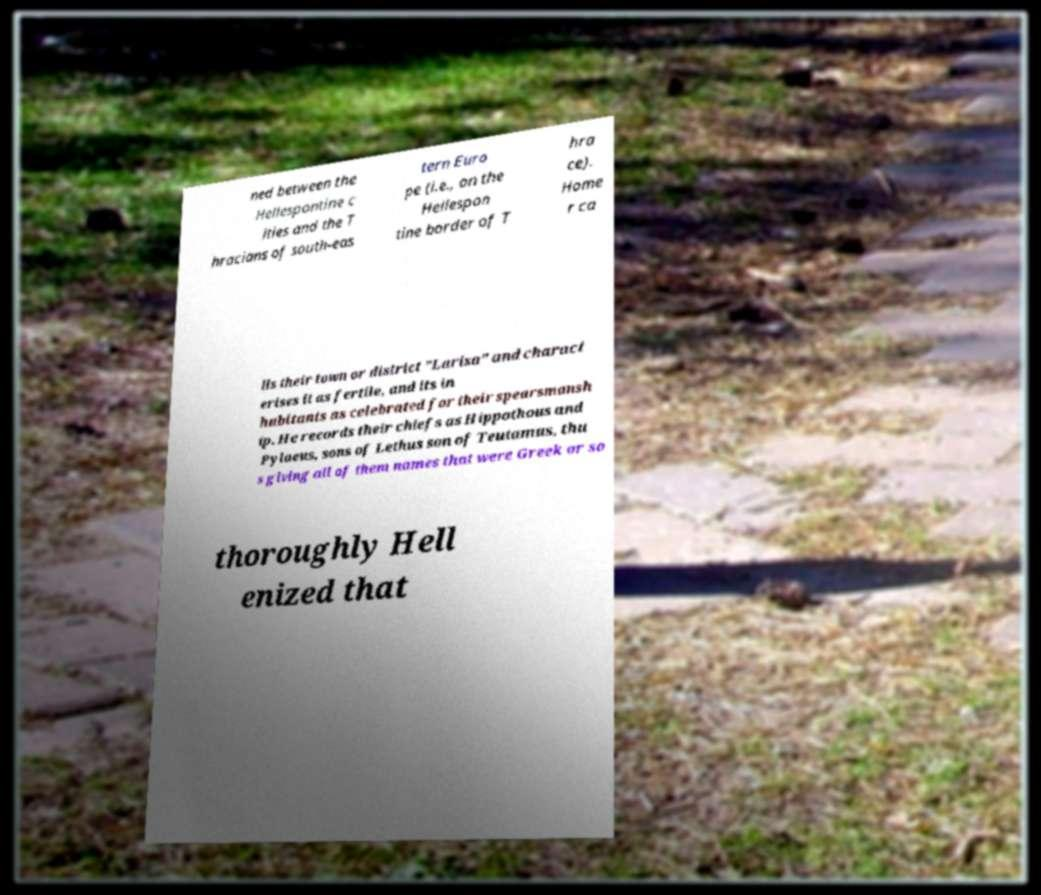For documentation purposes, I need the text within this image transcribed. Could you provide that? ned between the Hellespontine c ities and the T hracians of south-eas tern Euro pe (i.e., on the Hellespon tine border of T hra ce). Home r ca lls their town or district "Larisa" and charact erises it as fertile, and its in habitants as celebrated for their spearsmansh ip. He records their chiefs as Hippothous and Pylaeus, sons of Lethus son of Teutamus, thu s giving all of them names that were Greek or so thoroughly Hell enized that 